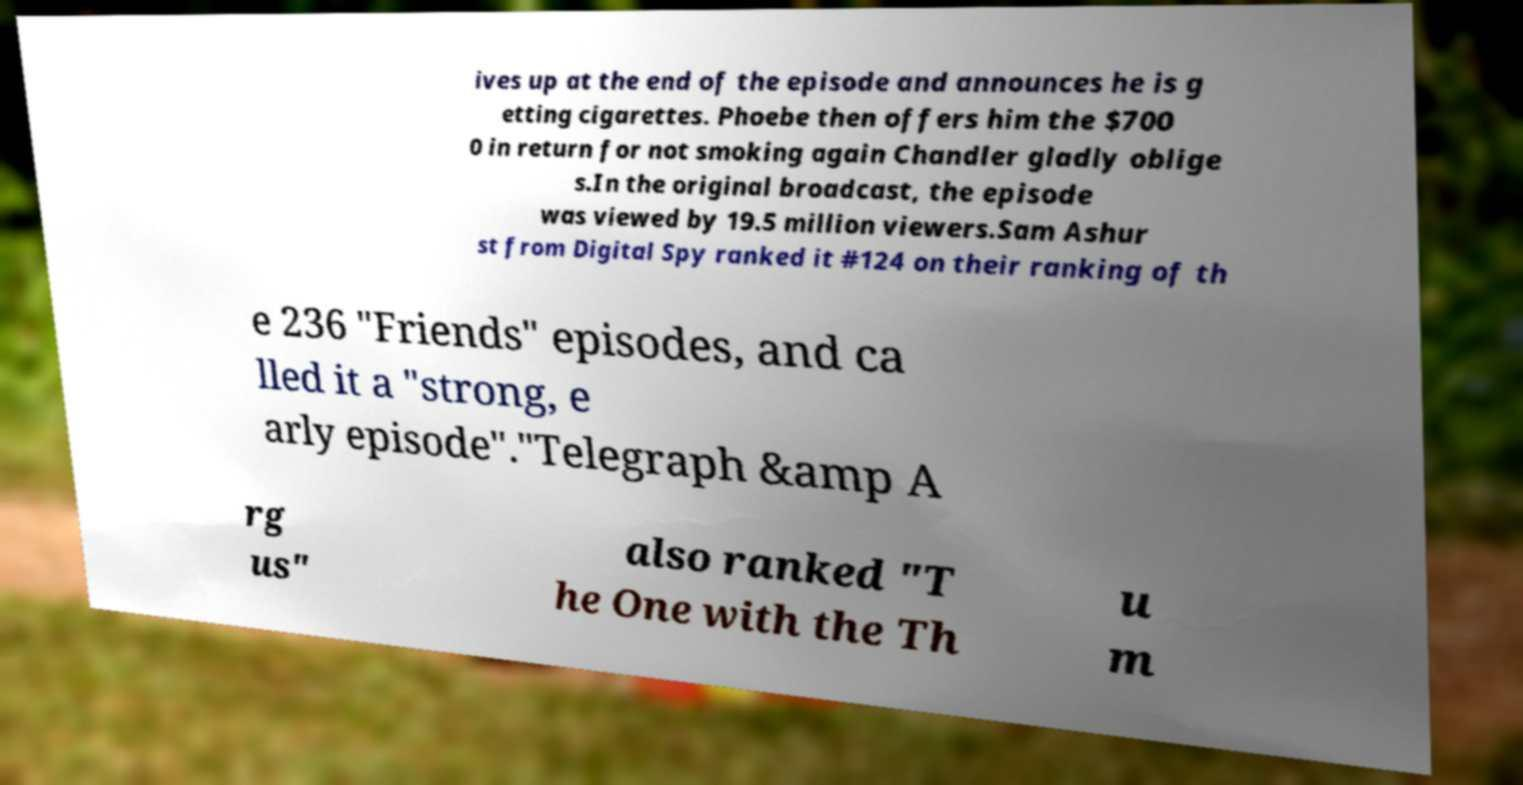What messages or text are displayed in this image? I need them in a readable, typed format. ives up at the end of the episode and announces he is g etting cigarettes. Phoebe then offers him the $700 0 in return for not smoking again Chandler gladly oblige s.In the original broadcast, the episode was viewed by 19.5 million viewers.Sam Ashur st from Digital Spy ranked it #124 on their ranking of th e 236 "Friends" episodes, and ca lled it a "strong, e arly episode"."Telegraph &amp A rg us" also ranked "T he One with the Th u m 